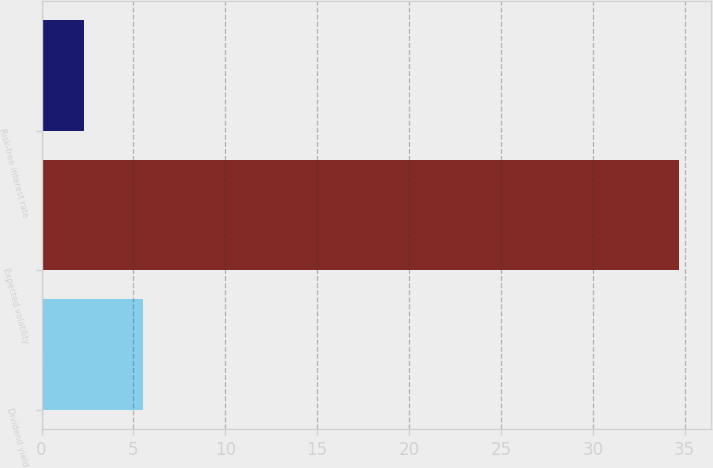<chart> <loc_0><loc_0><loc_500><loc_500><bar_chart><fcel>Dividend yield<fcel>Expected volatility<fcel>Risk-free interest rate<nl><fcel>5.54<fcel>34.7<fcel>2.3<nl></chart> 